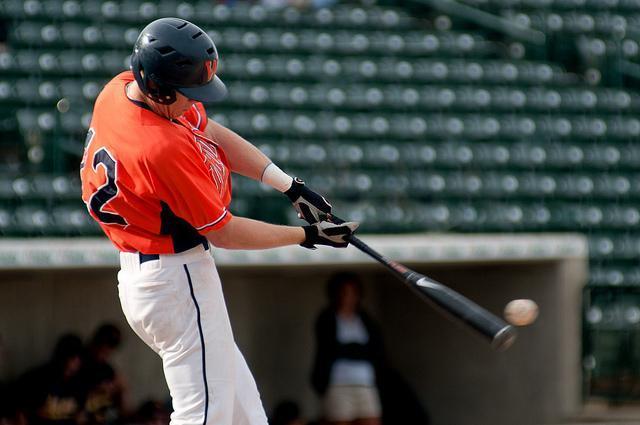How many people are visible?
Give a very brief answer. 3. 